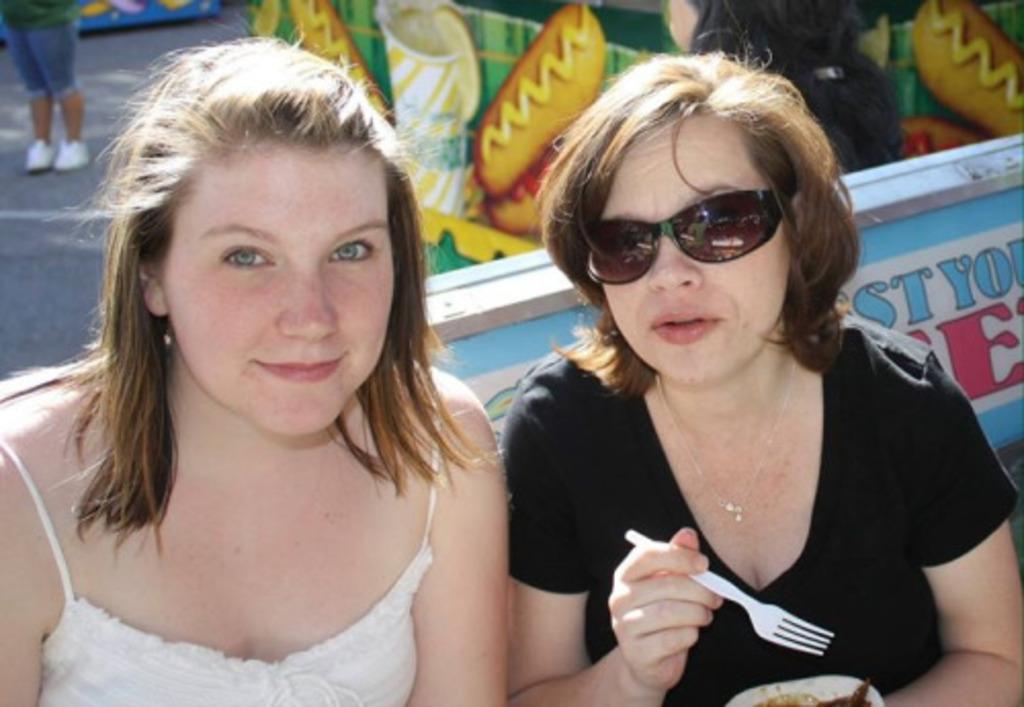Could you give a brief overview of what you see in this image? In this image, we can see people wearing clothes. There is a person on the right side of the image holding a fork with her hands. There are boards in the middle of the image. 